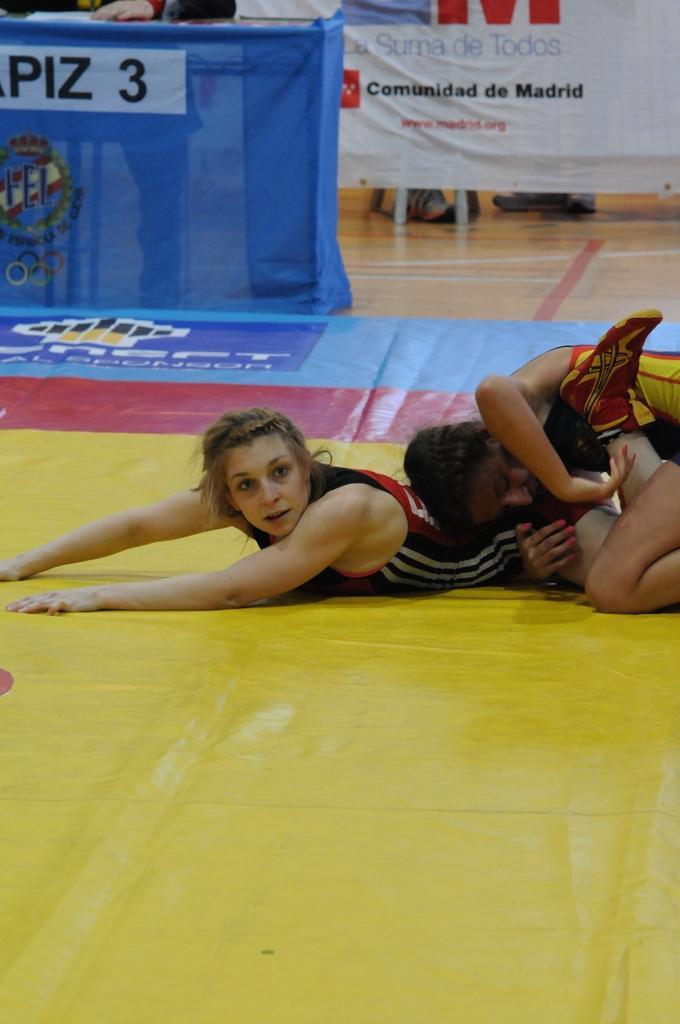Please provide a concise description of this image. In this image we can see a woman lying on the floor and there is an another person and it looks like they are performing wrestling. We can see some banners with the text and there is a person at the top of the image. 